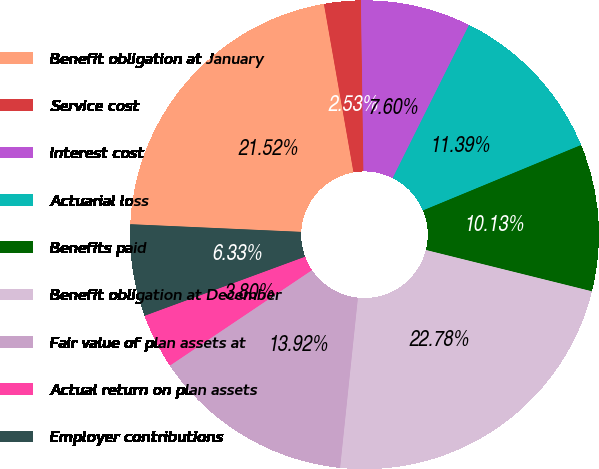Convert chart. <chart><loc_0><loc_0><loc_500><loc_500><pie_chart><fcel>Benefit obligation at January<fcel>Service cost<fcel>Interest cost<fcel>Actuarial loss<fcel>Benefits paid<fcel>Benefit obligation at December<fcel>Fair value of plan assets at<fcel>Actual return on plan assets<fcel>Employer contributions<nl><fcel>21.52%<fcel>2.53%<fcel>7.6%<fcel>11.39%<fcel>10.13%<fcel>22.78%<fcel>13.92%<fcel>3.8%<fcel>6.33%<nl></chart> 